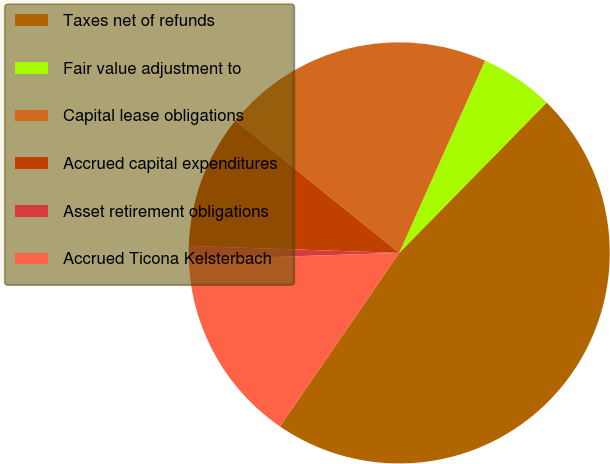Convert chart to OTSL. <chart><loc_0><loc_0><loc_500><loc_500><pie_chart><fcel>Taxes net of refunds<fcel>Fair value adjustment to<fcel>Capital lease obligations<fcel>Accrued capital expenditures<fcel>Asset retirement obligations<fcel>Accrued Ticona Kelsterbach<nl><fcel>47.23%<fcel>5.66%<fcel>20.88%<fcel>10.28%<fcel>1.04%<fcel>14.9%<nl></chart> 